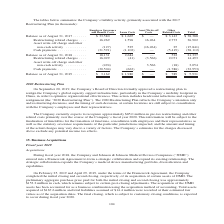According to Jabil Circuit's financial document, Why did the Company's Board of Directors formally approve a restructuring plan on September 15, 2016? Based on the financial document, the answer is to better align the Company’s global capacity and administrative support infrastructure to further optimize organizational effectiveness. Also, What was the total balance as of August 31, 2017? According to the financial document, $38,388 (in thousands). The relevant text states: "August 31, 2017 . $ 33,580 $ 1,665 $ — $ 3,143 $ 38,388 Restructuring related charges . 16,269 1,596 16,264 2,773 36,902 Asset write-off charge and other n..." Also, What was the total balance as of August 31, 2019? According to the financial document, $5,931 (in thousands). The relevant text states: "of August 31, 2019 . $ 3,162 $ 1,980 $ — $ 789 $ 5,931..." Also, can you calculate: What is the change in the balance as of August in Employee Severance and Benefit Costs between 2017 and 2018? Based on the calculation: 18,131-33,580, the result is -15449 (in thousands). This is based on the information: "Balance as of August 31, 2017 . $ 33,580 $ 1,665 $ — $ 3,143 $ 38,388 Restructuring related charges . 16,269 1,596 16,264 2,773 36,902 Asset Balance as of August 31, 2018 . 18,131 2,684 — 522 21,337 R..." The key data points involved are: 18,131, 33,580. Also, can you calculate: What were the lease costs in 2017 as a percentage of the total balance in 2017? Based on the calculation: 1,665/38,388, the result is 4.34 (percentage). This is based on the information: "August 31, 2017 . $ 33,580 $ 1,665 $ — $ 3,143 $ 38,388 Restructuring related charges . 16,269 1,596 16,264 2,773 36,902 Asset write-off charge and other n Balance as of August 31, 2017 . $ 33,580 $ 1..." The key data points involved are: 1,665, 38,388. Also, can you calculate: What was the percentage change in the total balance between 2018 and 2019? To answer this question, I need to perform calculations using the financial data. The calculation is: (5,931-21,337)/21,337, which equals -72.2 (percentage). This is based on the information: "alance as of August 31, 2018 . 18,131 2,684 — 522 21,337 Restructuring related charges . 16,029 (41) (3,566) 2,071 14,493 Asset write-off charge and other n of August 31, 2019 . $ 3,162 $ 1,980 $ — $ ..." The key data points involved are: 21,337, 5,931. 